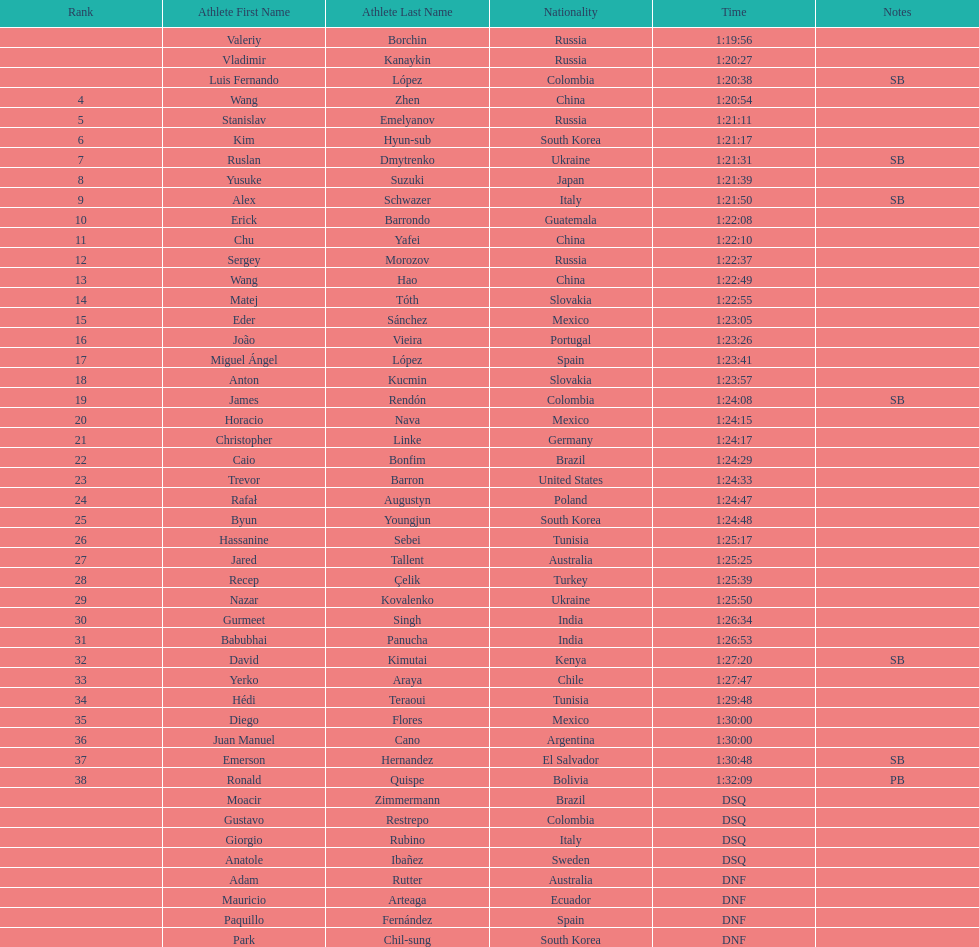How many competitors were from russia? 4. 